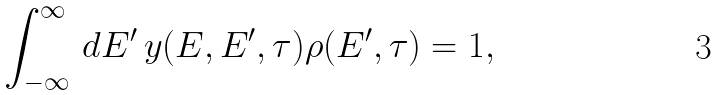Convert formula to latex. <formula><loc_0><loc_0><loc_500><loc_500>\int _ { - \infty } ^ { \infty } \, d E ^ { \prime } \, y ( E , E ^ { \prime } , \tau ) \rho ( E ^ { \prime } , \tau ) = 1 ,</formula> 